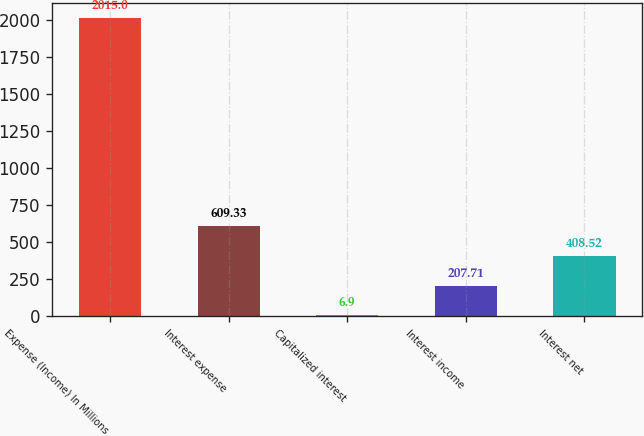Convert chart. <chart><loc_0><loc_0><loc_500><loc_500><bar_chart><fcel>Expense (Income) In Millions<fcel>Interest expense<fcel>Capitalized interest<fcel>Interest income<fcel>Interest net<nl><fcel>2015<fcel>609.33<fcel>6.9<fcel>207.71<fcel>408.52<nl></chart> 